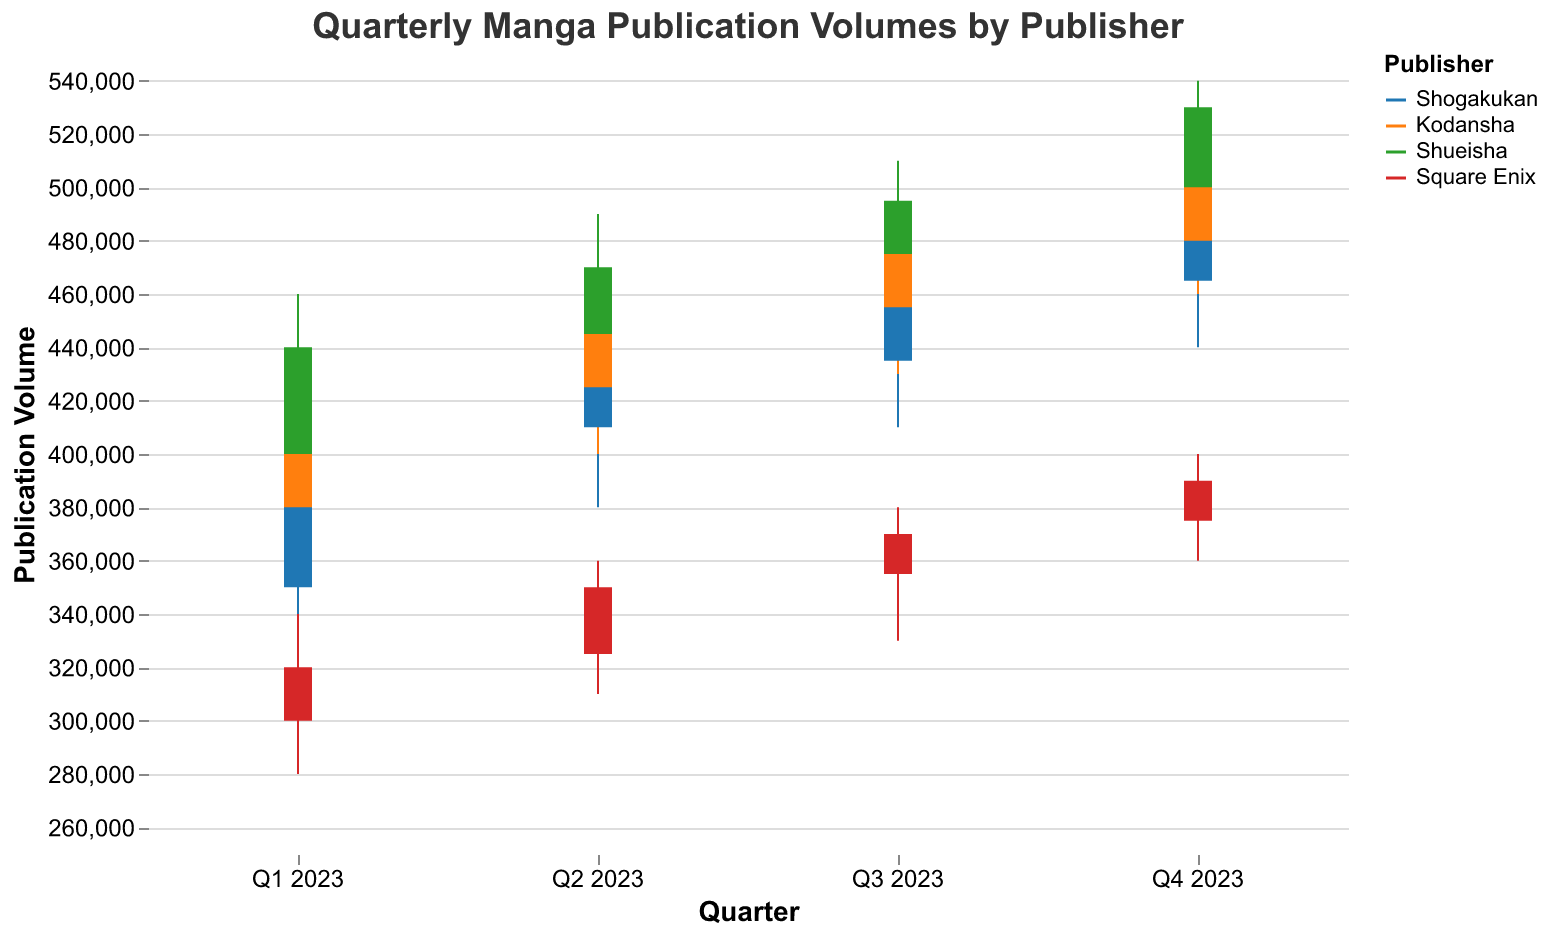What is the highest publication volume for Square Enix in any quarter? The highest publication volume for Square Enix is found in the 'High' values of the OHLC chart. Checking those, the highest value is 400000 in Q4 2023.
Answer: 400000 How did the publication volume for Kodansha change from Q3 2023 to Q4 2023? For Kodansha, in Q3 2023, the opening volume was 455000 and the closing volume was 475000; in Q4 2023, the opening was 480000, and the closing was 510000. The publication volume increased from 475000 to 510000.
Answer: Increased Which publisher had the lowest opening volume in Q1 2023? By analyzing the 'Open' values in Q1 2023, we have: Shogakukan - 350000, Kodansha - 380000, Shueisha - 400000, and Square Enix - 300000. Therefore, Square Enix had the lowest opening volume.
Answer: Square Enix What trend can be observed in Shogakukan's closing volumes throughout 2023? The closing volumes for Shogakukan increase from Q1 to Q4. Specifically, Q1 - 400000, Q2 - 430000, Q3 - 460000, and Q4 - 490000.
Answer: Increasing Compare the high volumes of Shueisha and Kodansha in Q4 2023. Which is higher? For Q4 2023, the 'High' value for Shueisha is 540000, while for Kodansha it is 520000. Shueisha's high volume is 20000 higher than Kodansha's.
Answer: Shueisha On which quarter did Shogakukan have the largest range in publication volumes? The range of publication volumes can be calculated by subtracting the 'Low' value from the 'High' value for each quarter. For Shogakukan: Q1 (420000 - 320000 = 100000), Q2 (450000 - 380000 = 70000), Q3 (480000 - 410000 = 70000), and Q4 (500000 - 440000 = 60000). Thus, the largest range is in Q1 2023.
Answer: Q1 2023 Did any publisher experience a decrease in closing volume in any quarter? To check for a decrease, compare the closing volumes of consecutive quarters. Shogakukan, Kodansha, Shueisha, and Square Enix all show increased closing volumes each quarter. Therefore, no publisher experienced a decrease.
Answer: No What is the average high volume for Kodansha in all quarters of 2023? Adding Kodansha’s high volumes: 440000 (Q1), 470000 (Q2), 490000 (Q3), 520000 (Q4) gives 1920000. Dividing by 4 quarters results in an average high volume of 480000.
Answer: 480000 Which publisher had the most stable (smallest range) publication volumes in Q4 2023? Calculating the range of 'High' and 'Low' for Q4 2023: Shogakukan (500000 - 440000 = 60000), Kodansha (520000 - 460000 = 60000), Shueisha (540000 - 480000 = 60000), Square Enix (400000 - 360000 = 40000). Square Enix had the smallest range of 40000.
Answer: Square Enix 